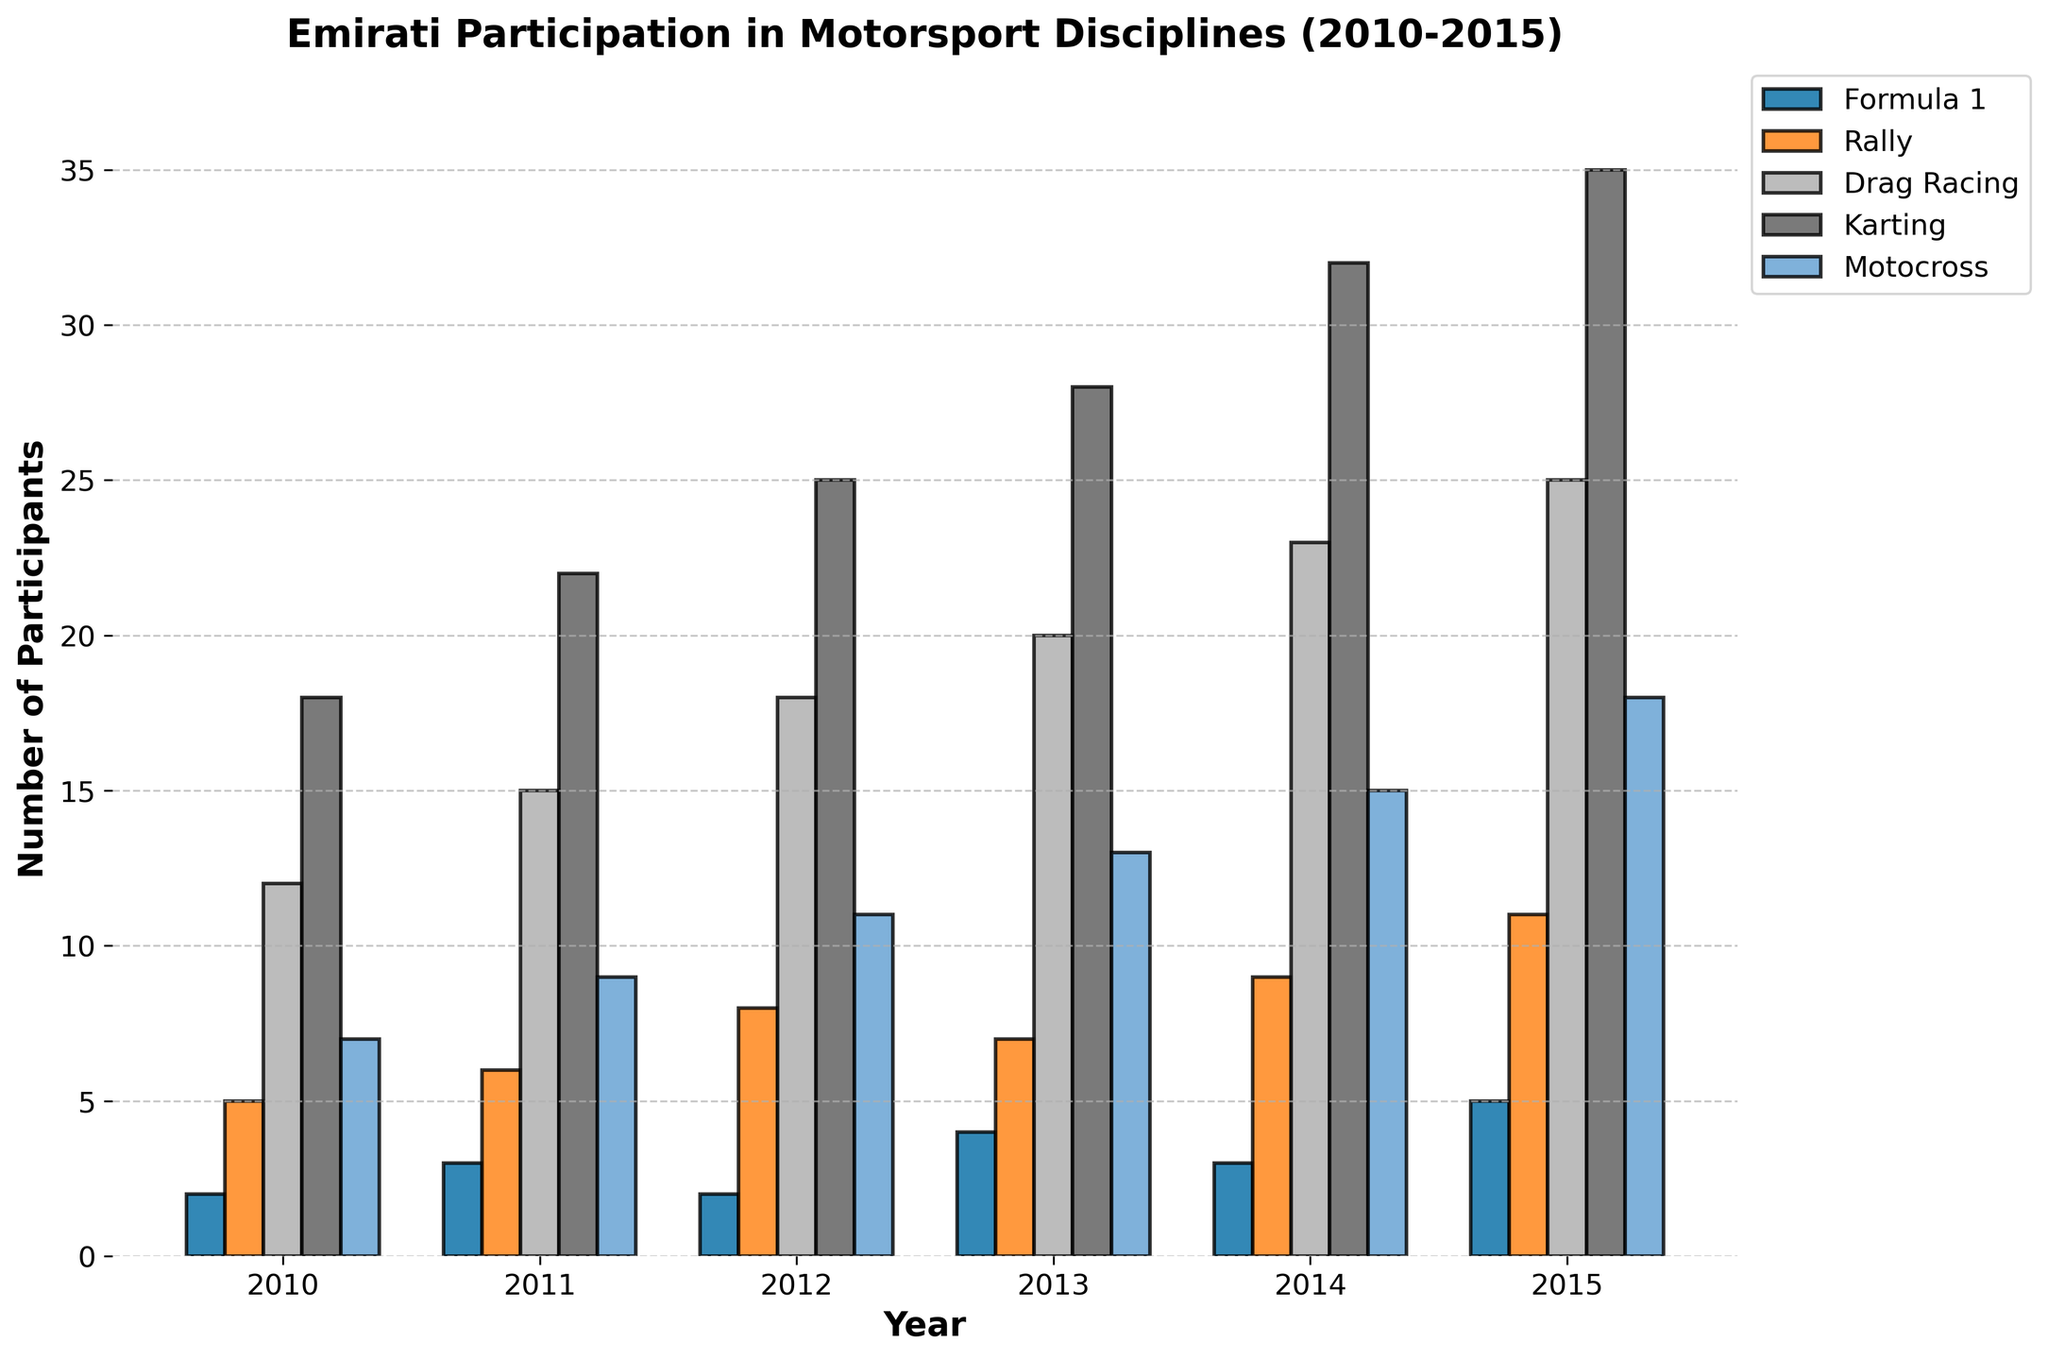What year saw the largest number of Emirati participants in Karting? The bar for Karting is highest in the year 2015.
Answer: 2015 How many more participants were there in Motocross in 2015 compared to 2013? The number of participants in Motocross in 2015 is 18, and in 2013 it is 13. The difference is 18 - 13 = 5.
Answer: 5 What was the average number of participants in Drag Racing from 2010 to 2015? The participant numbers are 12, 15, 18, 20, 23, and 25. Summing them gives 113. Dividing by 6 (the number of years): 113 / 6 ≈ 18.83.
Answer: 18.83 Which discipline had the least number of participants in 2012 and how many were there? The shortest bar for the year 2012 corresponds to Formula 1, with 2 participants.
Answer: Formula 1, 2 In which years did Rally have exactly 2 more participants than Formula 1? For 2010: Formula 1 = 2, Rally = 5 (not 2 more). For 2011: Formula 1 = 3, Rally = 6 (exactly 2 more). For 2012: Formula 1 = 2, Rally = 8 (more than 2). For 2013: Formula 1 = 4, Rally = 7 (not 2 more). For 2014: Formula 1 = 3, Rally = 9 (more than 2). For 2015: Formula 1 = 5, Rally = 11 (exactly 2 more). Therefore, the years are 2011 and 2015.
Answer: 2011, 2015 What is the total number of Emirati participants in all disciplines combined in 2014? Summing across all disciplines for 2014: 3 (Formula 1) + 9 (Rally) + 23 (Drag Racing) + 32 (Karting) + 15 (Motocross) = 82.
Answer: 82 Which discipline saw the greatest increase in participants from 2010 to 2015? Comparing the bar heights for 2010 and 2015, the increments are Formula 1: 3, Rally: 6, Drag Racing: 13, Karting: 17, Motocross: 11. The largest increase is in Karting.
Answer: Karting How did the number of Karting participants change from 2011 to 2015? In 2011, there were 22 participants, and in 2015, there were 35. The change is 35 - 22 = 13.
Answer: Increased by 13 What is the difference in the number of participants between Drag Racing and Motocross in 2015? In 2015, Drag Racing has 25 participants, and Motocross has 18. The difference is 25 - 18 = 7.
Answer: 7 